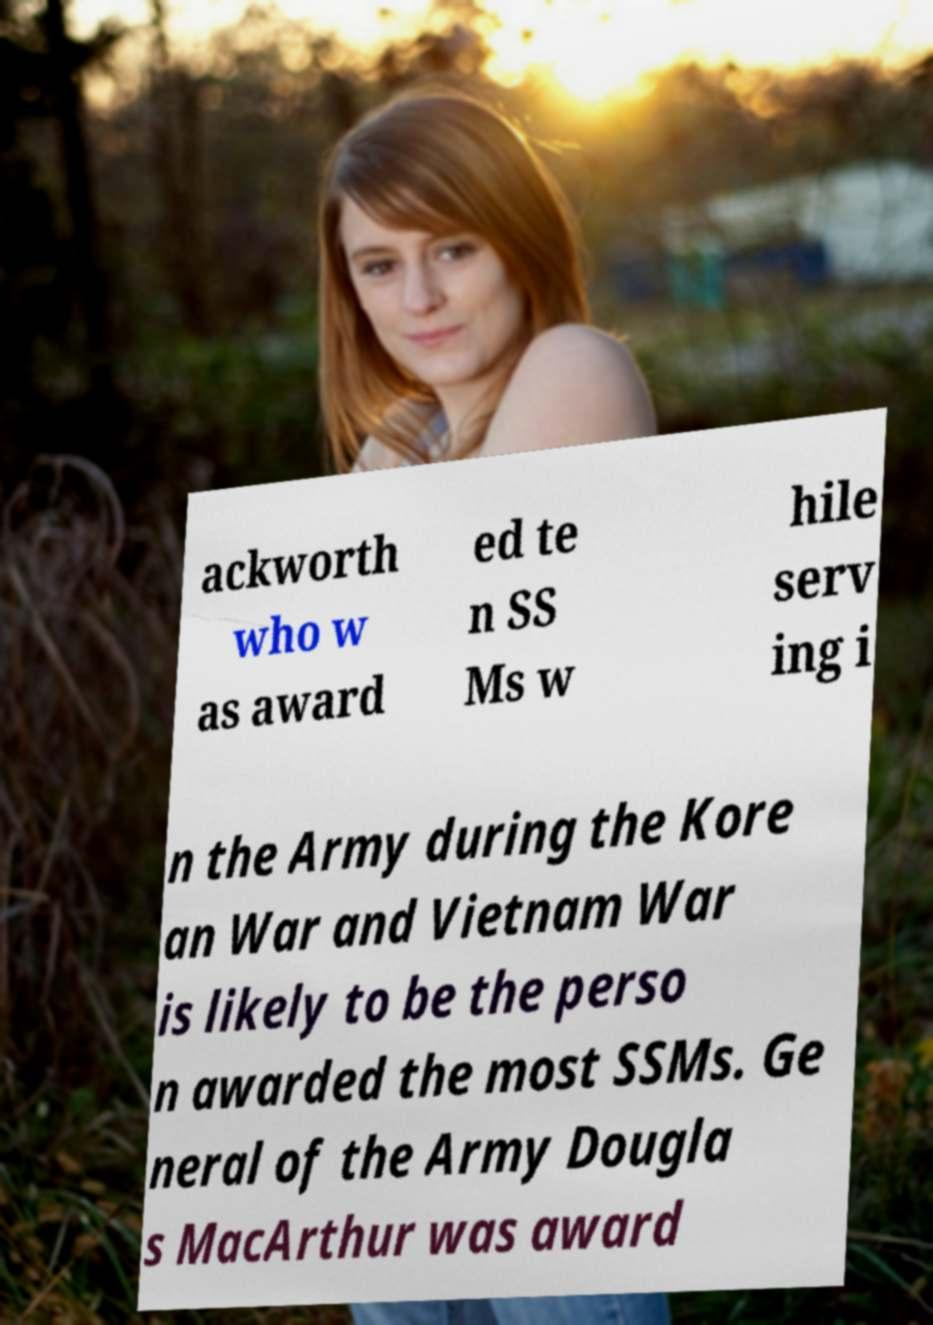Could you assist in decoding the text presented in this image and type it out clearly? ackworth who w as award ed te n SS Ms w hile serv ing i n the Army during the Kore an War and Vietnam War is likely to be the perso n awarded the most SSMs. Ge neral of the Army Dougla s MacArthur was award 